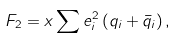<formula> <loc_0><loc_0><loc_500><loc_500>F _ { 2 } = x \sum e _ { i } ^ { 2 } \left ( q _ { i } + \bar { q } _ { i } \right ) ,</formula> 